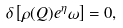<formula> <loc_0><loc_0><loc_500><loc_500>\delta \left [ \rho ( Q ) e ^ { \eta } \omega \right ] = 0 ,</formula> 